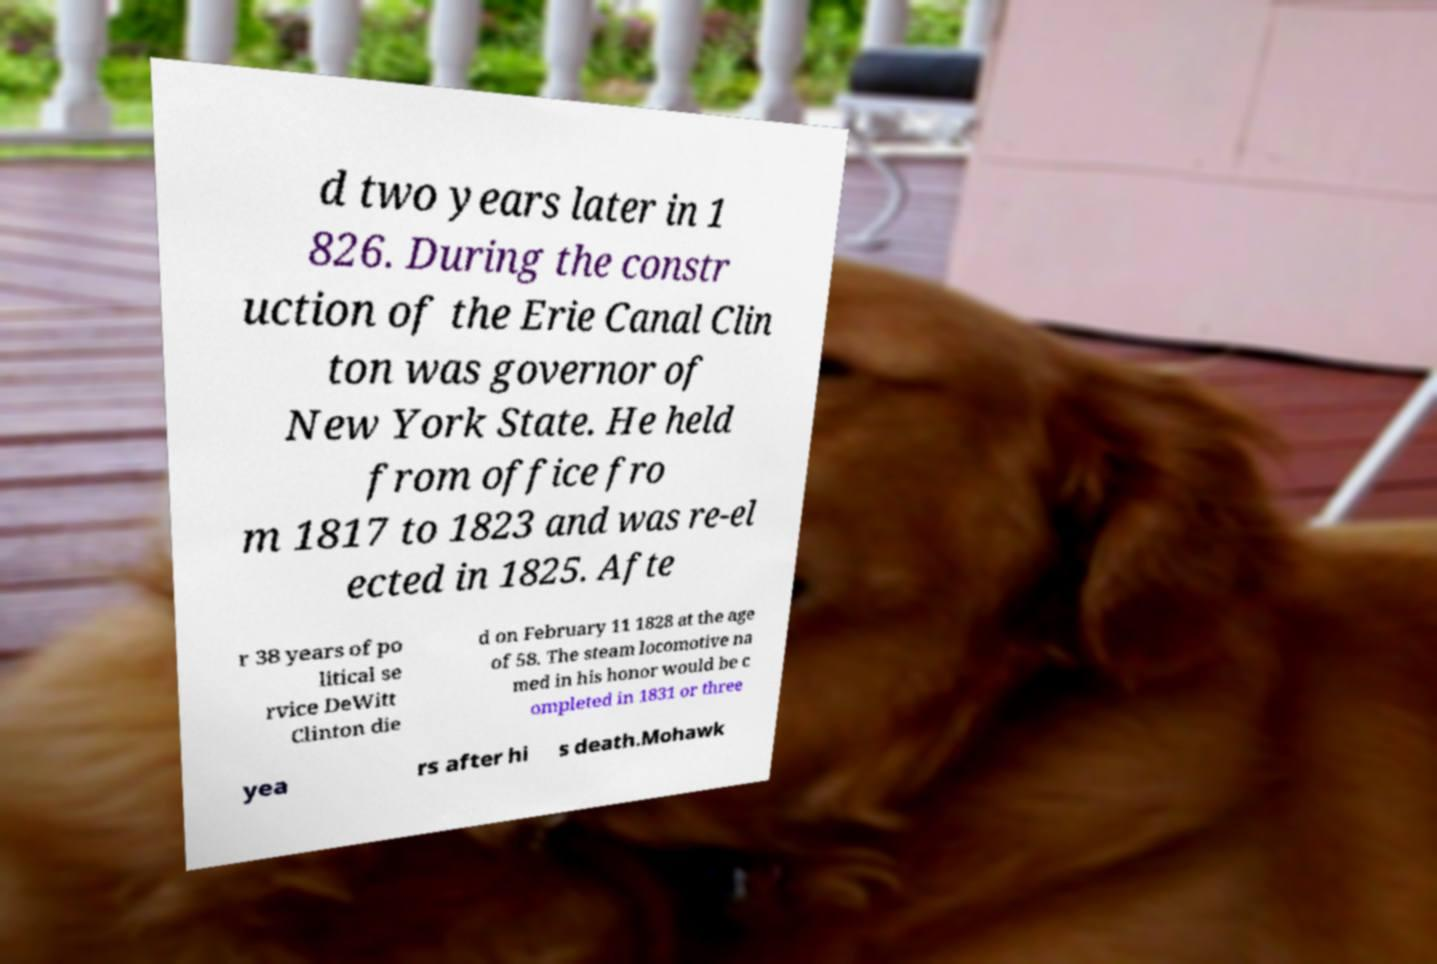What messages or text are displayed in this image? I need them in a readable, typed format. d two years later in 1 826. During the constr uction of the Erie Canal Clin ton was governor of New York State. He held from office fro m 1817 to 1823 and was re-el ected in 1825. Afte r 38 years of po litical se rvice DeWitt Clinton die d on February 11 1828 at the age of 58. The steam locomotive na med in his honor would be c ompleted in 1831 or three yea rs after hi s death.Mohawk 